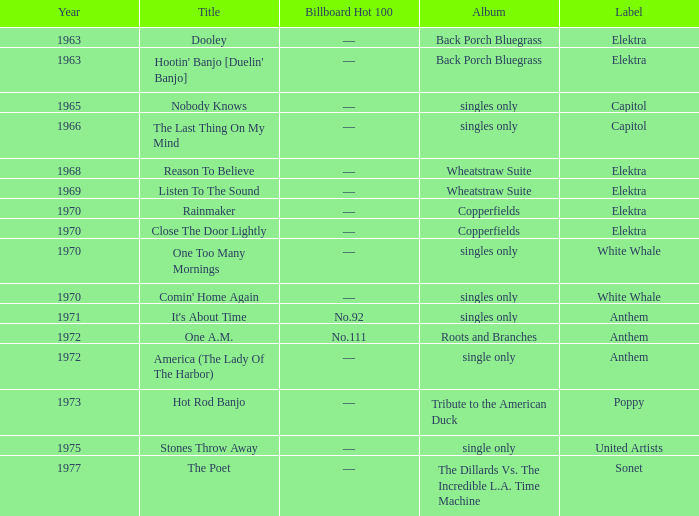What is the total years for roots and branches? 1972.0. 